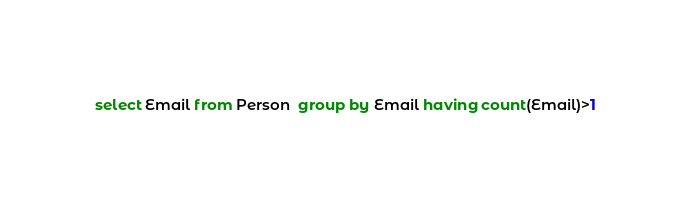Convert code to text. <code><loc_0><loc_0><loc_500><loc_500><_SQL_>select Email from Person  group by Email having count(Email)>1</code> 